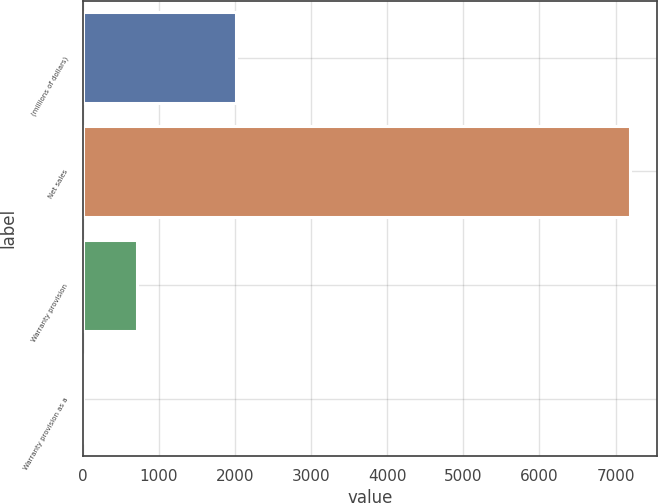Convert chart to OTSL. <chart><loc_0><loc_0><loc_500><loc_500><bar_chart><fcel>(millions of dollars)<fcel>Net sales<fcel>Warranty provision<fcel>Warranty provision as a<nl><fcel>2012<fcel>7183.2<fcel>718.77<fcel>0.5<nl></chart> 